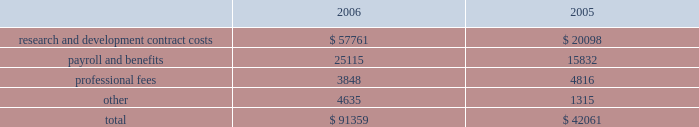Vertex pharmaceuticals incorporated notes to consolidated financial statements ( continued ) i .
Altus investment ( continued ) of the offering , held 450000 shares of redeemable preferred stock , which are not convertible into common stock and which are redeemable for $ 10.00 per share plus annual dividends of $ 0.50 per share , which have been accruing since the redeemable preferred stock was issued in 1999 , at vertex 2019s option on or after december 31 , 2010 , or by altus at any time .
The company was restricted from trading altus securities for a period of six months following the initial public offering .
When the altus securities trading restrictions expired , the company sold the 817749 shares of altus common stock for approximately $ 11.7 million , resulting in a realized gain of approximately $ 7.7 million in august 2006 .
Additionally when the restrictions expired , the company began accounting for the altus warrants as derivative instruments under the financial accounting standards board statement no .
Fas 133 , 201caccounting for derivative instruments and hedging activities 201d ( 201cfas 133 201d ) .
In accordance with fas 133 , in the third quarter of 2006 , the company recorded the altus warrants on its consolidated balance sheet at a fair market value of $ 19.1 million and recorded an unrealized gain on the fair market value of the altus warrants of $ 4.3 million .
In the fourth quarter of 2006 the company sold the altus warrants for approximately $ 18.3 million , resulting in a realized loss of $ 0.7 million .
As a result of the company 2019s sales of altus common stock and altus warrrants in 2006 , the company recorded a realized gain on a sale of investment of $ 11.2 million .
In accordance with the company 2019s policy , as outlined in note b , 201caccounting policies , 201d the company assessed its investment in altus , which it accounts for using the cost method , and determined that there had not been any adjustments to the fair values of that investment that would require the company to write down the investment basis of the asset , in 2005 and 2006 .
The company 2019s cost basis carrying value in its outstanding equity and warrants of altus was $ 18.9 million at december 31 , 2005 .
Accrued expenses and other current liabilities accrued expenses and other current liabilities consist of the following at december 31 ( in thousands ) : k .
Commitments the company leases its facilities and certain equipment under non-cancelable operating leases .
The company 2019s leases have terms through april 2018 .
The term of the kendall square lease began january 1 , 2003 and lease payments commenced in may 2003 .
The company had an obligation under the kendall square lease , staged through 2006 , to build-out the space into finished laboratory and office space .
This lease will expire in 2018 , and the company has the option to extend the term for two consecutive terms of ten years each , ultimately expiring in 2038 .
The company occupies and uses for its operations approximately 120000 square feet of the kendall square facility .
The company has sublease arrangements in place for the remaining rentable square footage of the kendall square facility , with initial terms that expires in april 2011 and august 2012 .
See note e , 201crestructuring 201d for further information. .
Research and development contract costs $ 57761 $ 20098 payroll and benefits 25115 15832 professional fees 3848 4816 4635 1315 $ 91359 $ 42061 .
As part of the restructuring additional information what was the percent of the 2 research and development contract costs to the total cost in 2006? 
Computations: (57761 / 91359)
Answer: 0.63224. 